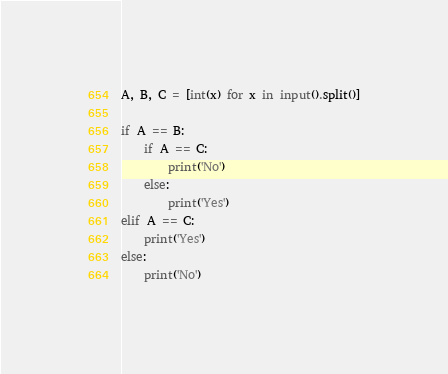<code> <loc_0><loc_0><loc_500><loc_500><_Python_>A, B, C = [int(x) for x in input().split()]

if A == B:
    if A == C:
        print('No')
    else:
        print('Yes')
elif A == C:
    print('Yes')
else:
    print('No')</code> 